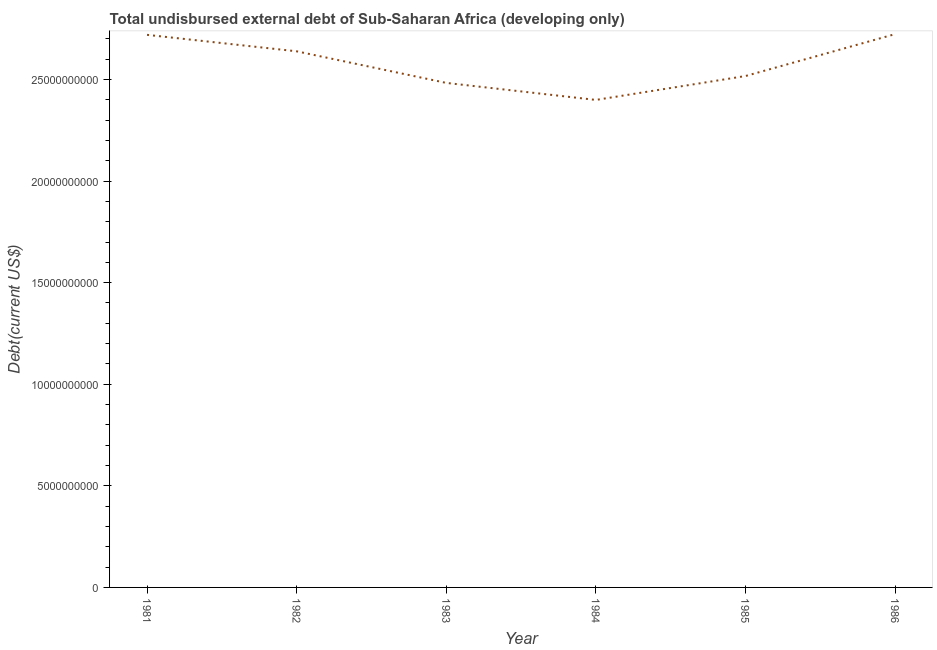What is the total debt in 1984?
Ensure brevity in your answer.  2.40e+1. Across all years, what is the maximum total debt?
Offer a terse response. 2.72e+1. Across all years, what is the minimum total debt?
Your answer should be very brief. 2.40e+1. What is the sum of the total debt?
Offer a very short reply. 1.55e+11. What is the difference between the total debt in 1984 and 1985?
Provide a succinct answer. -1.18e+09. What is the average total debt per year?
Offer a terse response. 2.58e+1. What is the median total debt?
Provide a short and direct response. 2.58e+1. In how many years, is the total debt greater than 13000000000 US$?
Provide a short and direct response. 6. What is the ratio of the total debt in 1983 to that in 1984?
Provide a succinct answer. 1.03. Is the total debt in 1985 less than that in 1986?
Provide a succinct answer. Yes. Is the difference between the total debt in 1981 and 1982 greater than the difference between any two years?
Offer a very short reply. No. What is the difference between the highest and the second highest total debt?
Keep it short and to the point. 3.59e+07. Is the sum of the total debt in 1983 and 1984 greater than the maximum total debt across all years?
Keep it short and to the point. Yes. What is the difference between the highest and the lowest total debt?
Make the answer very short. 3.24e+09. In how many years, is the total debt greater than the average total debt taken over all years?
Offer a terse response. 3. Does the total debt monotonically increase over the years?
Offer a very short reply. No. How many lines are there?
Make the answer very short. 1. What is the difference between two consecutive major ticks on the Y-axis?
Keep it short and to the point. 5.00e+09. Are the values on the major ticks of Y-axis written in scientific E-notation?
Provide a short and direct response. No. What is the title of the graph?
Give a very brief answer. Total undisbursed external debt of Sub-Saharan Africa (developing only). What is the label or title of the Y-axis?
Your answer should be very brief. Debt(current US$). What is the Debt(current US$) in 1981?
Provide a succinct answer. 2.72e+1. What is the Debt(current US$) in 1982?
Your response must be concise. 2.64e+1. What is the Debt(current US$) of 1983?
Give a very brief answer. 2.48e+1. What is the Debt(current US$) in 1984?
Provide a short and direct response. 2.40e+1. What is the Debt(current US$) of 1985?
Offer a very short reply. 2.52e+1. What is the Debt(current US$) of 1986?
Offer a terse response. 2.72e+1. What is the difference between the Debt(current US$) in 1981 and 1982?
Your answer should be compact. 8.10e+08. What is the difference between the Debt(current US$) in 1981 and 1983?
Offer a very short reply. 2.37e+09. What is the difference between the Debt(current US$) in 1981 and 1984?
Keep it short and to the point. 3.20e+09. What is the difference between the Debt(current US$) in 1981 and 1985?
Give a very brief answer. 2.03e+09. What is the difference between the Debt(current US$) in 1981 and 1986?
Your answer should be compact. -3.59e+07. What is the difference between the Debt(current US$) in 1982 and 1983?
Provide a succinct answer. 1.56e+09. What is the difference between the Debt(current US$) in 1982 and 1984?
Provide a short and direct response. 2.39e+09. What is the difference between the Debt(current US$) in 1982 and 1985?
Offer a terse response. 1.22e+09. What is the difference between the Debt(current US$) in 1982 and 1986?
Keep it short and to the point. -8.46e+08. What is the difference between the Debt(current US$) in 1983 and 1984?
Offer a very short reply. 8.38e+08. What is the difference between the Debt(current US$) in 1983 and 1985?
Your response must be concise. -3.39e+08. What is the difference between the Debt(current US$) in 1983 and 1986?
Make the answer very short. -2.40e+09. What is the difference between the Debt(current US$) in 1984 and 1985?
Offer a very short reply. -1.18e+09. What is the difference between the Debt(current US$) in 1984 and 1986?
Give a very brief answer. -3.24e+09. What is the difference between the Debt(current US$) in 1985 and 1986?
Keep it short and to the point. -2.06e+09. What is the ratio of the Debt(current US$) in 1981 to that in 1982?
Your response must be concise. 1.03. What is the ratio of the Debt(current US$) in 1981 to that in 1983?
Offer a terse response. 1.09. What is the ratio of the Debt(current US$) in 1981 to that in 1984?
Keep it short and to the point. 1.13. What is the ratio of the Debt(current US$) in 1981 to that in 1985?
Your answer should be compact. 1.08. What is the ratio of the Debt(current US$) in 1982 to that in 1983?
Offer a very short reply. 1.06. What is the ratio of the Debt(current US$) in 1982 to that in 1985?
Offer a very short reply. 1.05. What is the ratio of the Debt(current US$) in 1983 to that in 1984?
Offer a terse response. 1.03. What is the ratio of the Debt(current US$) in 1983 to that in 1986?
Make the answer very short. 0.91. What is the ratio of the Debt(current US$) in 1984 to that in 1985?
Give a very brief answer. 0.95. What is the ratio of the Debt(current US$) in 1984 to that in 1986?
Offer a terse response. 0.88. What is the ratio of the Debt(current US$) in 1985 to that in 1986?
Ensure brevity in your answer.  0.92. 